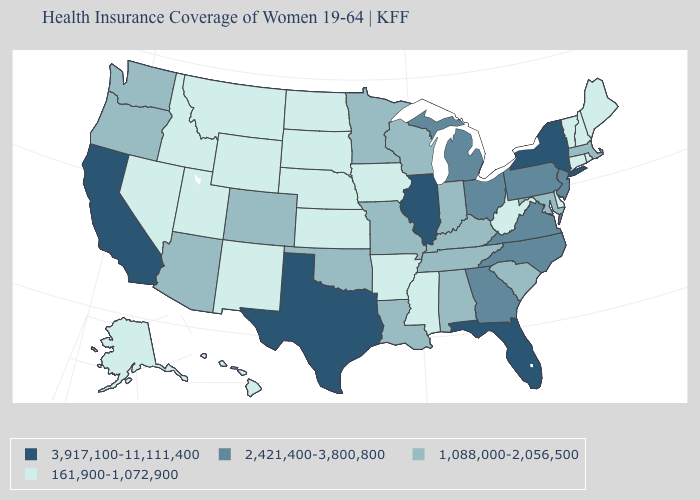Does Texas have the highest value in the South?
Quick response, please. Yes. Name the states that have a value in the range 1,088,000-2,056,500?
Answer briefly. Alabama, Arizona, Colorado, Indiana, Kentucky, Louisiana, Maryland, Massachusetts, Minnesota, Missouri, Oklahoma, Oregon, South Carolina, Tennessee, Washington, Wisconsin. What is the value of Nevada?
Write a very short answer. 161,900-1,072,900. Which states have the lowest value in the South?
Short answer required. Arkansas, Delaware, Mississippi, West Virginia. What is the value of Connecticut?
Be succinct. 161,900-1,072,900. What is the value of Arkansas?
Quick response, please. 161,900-1,072,900. What is the value of Washington?
Quick response, please. 1,088,000-2,056,500. What is the lowest value in the USA?
Give a very brief answer. 161,900-1,072,900. Name the states that have a value in the range 2,421,400-3,800,800?
Give a very brief answer. Georgia, Michigan, New Jersey, North Carolina, Ohio, Pennsylvania, Virginia. What is the value of Alaska?
Answer briefly. 161,900-1,072,900. Does Delaware have the lowest value in the USA?
Answer briefly. Yes. What is the value of Louisiana?
Write a very short answer. 1,088,000-2,056,500. Name the states that have a value in the range 3,917,100-11,111,400?
Be succinct. California, Florida, Illinois, New York, Texas. What is the lowest value in states that border Mississippi?
Concise answer only. 161,900-1,072,900. Which states have the lowest value in the USA?
Short answer required. Alaska, Arkansas, Connecticut, Delaware, Hawaii, Idaho, Iowa, Kansas, Maine, Mississippi, Montana, Nebraska, Nevada, New Hampshire, New Mexico, North Dakota, Rhode Island, South Dakota, Utah, Vermont, West Virginia, Wyoming. 